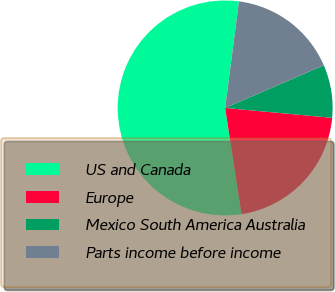<chart> <loc_0><loc_0><loc_500><loc_500><pie_chart><fcel>US and Canada<fcel>Europe<fcel>Mexico South America Australia<fcel>Parts income before income<nl><fcel>54.48%<fcel>21.1%<fcel>7.97%<fcel>16.45%<nl></chart> 